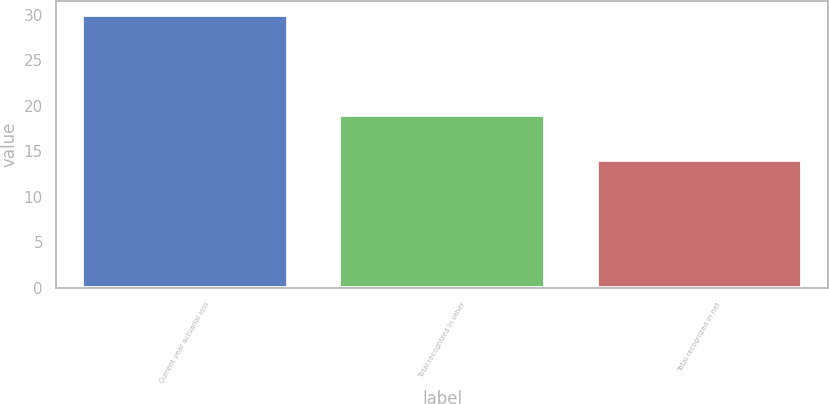Convert chart to OTSL. <chart><loc_0><loc_0><loc_500><loc_500><bar_chart><fcel>Current year actuarial loss<fcel>Total recognized in other<fcel>Total recognized in net<nl><fcel>30<fcel>19<fcel>14<nl></chart> 